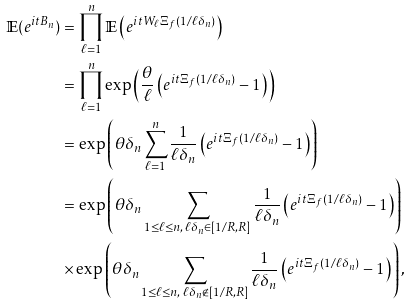<formula> <loc_0><loc_0><loc_500><loc_500>\mathbb { E } ( e ^ { i t B _ { n } } ) & = \prod _ { \ell = 1 } ^ { n } \mathbb { E } \left ( e ^ { i t W _ { \ell } \Xi _ { f } ( 1 / \ell \delta _ { n } ) } \right ) \\ & = \prod _ { \ell = 1 } ^ { n } \exp \left ( \frac { \theta } { \ell } \left ( e ^ { i t \Xi _ { f } ( 1 / \ell \delta _ { n } ) } - 1 \right ) \right ) \\ & = \exp \left ( \theta \delta _ { n } \sum _ { \ell = 1 } ^ { n } \frac { 1 } { \ell \delta _ { n } } \left ( e ^ { i t \Xi _ { f } ( 1 / \ell \delta _ { n } ) } - 1 \right ) \right ) \\ & = \exp \left ( \theta \delta _ { n } \sum _ { 1 \leq \ell \leq n , \, \ell \delta _ { n } \in [ 1 / R , R ] } \frac { 1 } { \ell \delta _ { n } } \left ( e ^ { i t \Xi _ { f } ( 1 / \ell \delta _ { n } ) } - 1 \right ) \right ) \\ & \times \exp \left ( \theta \delta _ { n } \sum _ { 1 \leq \ell \leq n , \, \ell \delta _ { n } \notin [ 1 / R , R ] } \frac { 1 } { \ell \delta _ { n } } \left ( e ^ { i t \Xi _ { f } ( 1 / \ell \delta _ { n } ) } - 1 \right ) \right ) ,</formula> 